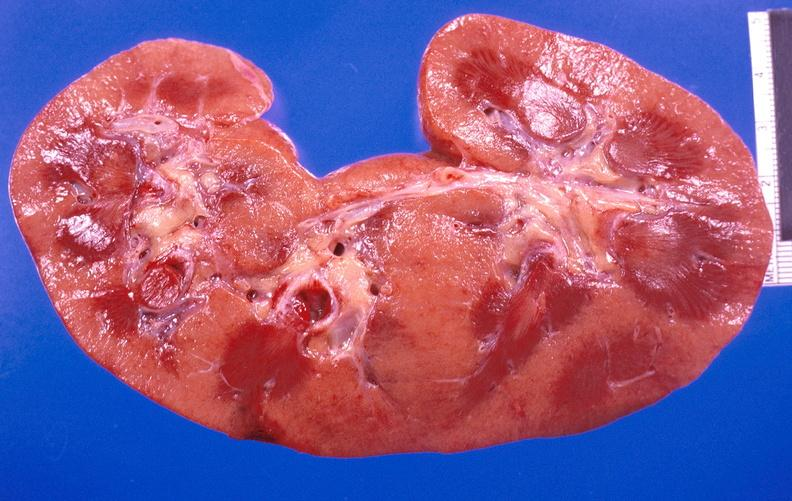what does this image show?
Answer the question using a single word or phrase. Kidney aspergillosis 